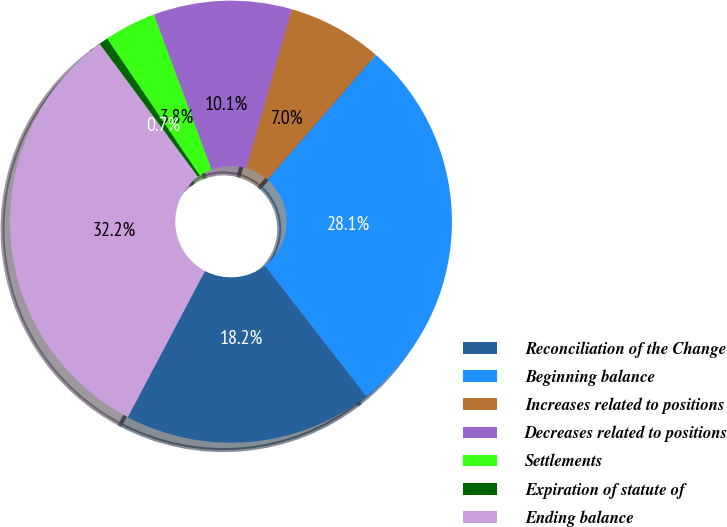<chart> <loc_0><loc_0><loc_500><loc_500><pie_chart><fcel>Reconciliation of the Change<fcel>Beginning balance<fcel>Increases related to positions<fcel>Decreases related to positions<fcel>Settlements<fcel>Expiration of statute of<fcel>Ending balance<nl><fcel>18.23%<fcel>28.1%<fcel>6.95%<fcel>10.1%<fcel>3.8%<fcel>0.65%<fcel>32.15%<nl></chart> 